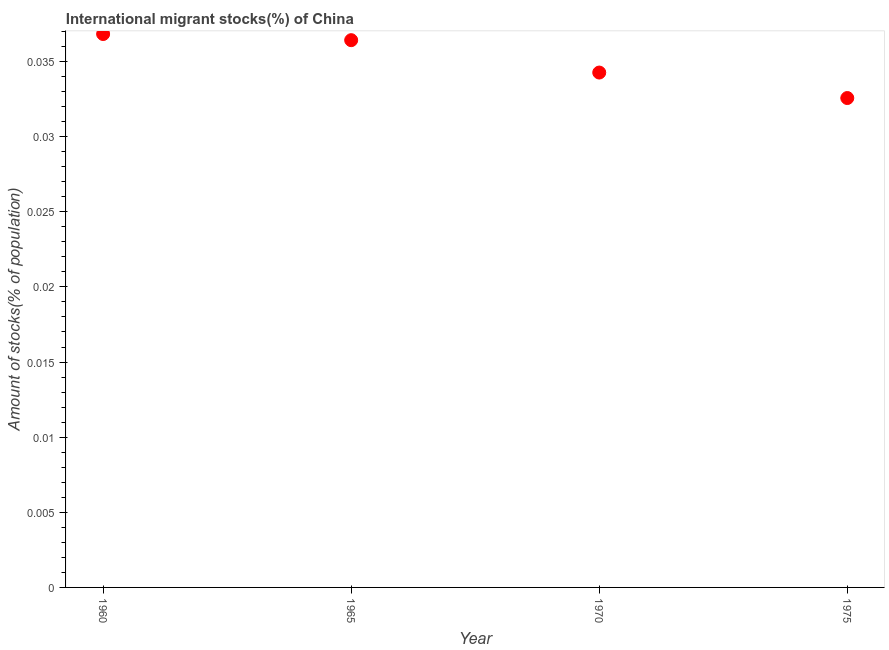What is the number of international migrant stocks in 1970?
Offer a terse response. 0.03. Across all years, what is the maximum number of international migrant stocks?
Your response must be concise. 0.04. Across all years, what is the minimum number of international migrant stocks?
Your answer should be compact. 0.03. In which year was the number of international migrant stocks minimum?
Give a very brief answer. 1975. What is the sum of the number of international migrant stocks?
Provide a succinct answer. 0.14. What is the difference between the number of international migrant stocks in 1965 and 1975?
Your answer should be very brief. 0. What is the average number of international migrant stocks per year?
Give a very brief answer. 0.04. What is the median number of international migrant stocks?
Your answer should be compact. 0.04. What is the ratio of the number of international migrant stocks in 1960 to that in 1970?
Your answer should be very brief. 1.07. Is the number of international migrant stocks in 1960 less than that in 1970?
Make the answer very short. No. Is the difference between the number of international migrant stocks in 1960 and 1965 greater than the difference between any two years?
Make the answer very short. No. What is the difference between the highest and the second highest number of international migrant stocks?
Keep it short and to the point. 0. What is the difference between the highest and the lowest number of international migrant stocks?
Your answer should be very brief. 0. In how many years, is the number of international migrant stocks greater than the average number of international migrant stocks taken over all years?
Make the answer very short. 2. How many dotlines are there?
Your response must be concise. 1. What is the difference between two consecutive major ticks on the Y-axis?
Give a very brief answer. 0.01. Does the graph contain any zero values?
Provide a short and direct response. No. Does the graph contain grids?
Your response must be concise. No. What is the title of the graph?
Make the answer very short. International migrant stocks(%) of China. What is the label or title of the Y-axis?
Make the answer very short. Amount of stocks(% of population). What is the Amount of stocks(% of population) in 1960?
Your answer should be compact. 0.04. What is the Amount of stocks(% of population) in 1965?
Offer a terse response. 0.04. What is the Amount of stocks(% of population) in 1970?
Ensure brevity in your answer.  0.03. What is the Amount of stocks(% of population) in 1975?
Offer a very short reply. 0.03. What is the difference between the Amount of stocks(% of population) in 1960 and 1965?
Make the answer very short. 0. What is the difference between the Amount of stocks(% of population) in 1960 and 1970?
Offer a very short reply. 0. What is the difference between the Amount of stocks(% of population) in 1960 and 1975?
Give a very brief answer. 0. What is the difference between the Amount of stocks(% of population) in 1965 and 1970?
Your response must be concise. 0. What is the difference between the Amount of stocks(% of population) in 1965 and 1975?
Make the answer very short. 0. What is the difference between the Amount of stocks(% of population) in 1970 and 1975?
Offer a very short reply. 0. What is the ratio of the Amount of stocks(% of population) in 1960 to that in 1965?
Your response must be concise. 1.01. What is the ratio of the Amount of stocks(% of population) in 1960 to that in 1970?
Provide a succinct answer. 1.07. What is the ratio of the Amount of stocks(% of population) in 1960 to that in 1975?
Your response must be concise. 1.13. What is the ratio of the Amount of stocks(% of population) in 1965 to that in 1970?
Ensure brevity in your answer.  1.06. What is the ratio of the Amount of stocks(% of population) in 1965 to that in 1975?
Your answer should be compact. 1.12. What is the ratio of the Amount of stocks(% of population) in 1970 to that in 1975?
Offer a very short reply. 1.05. 